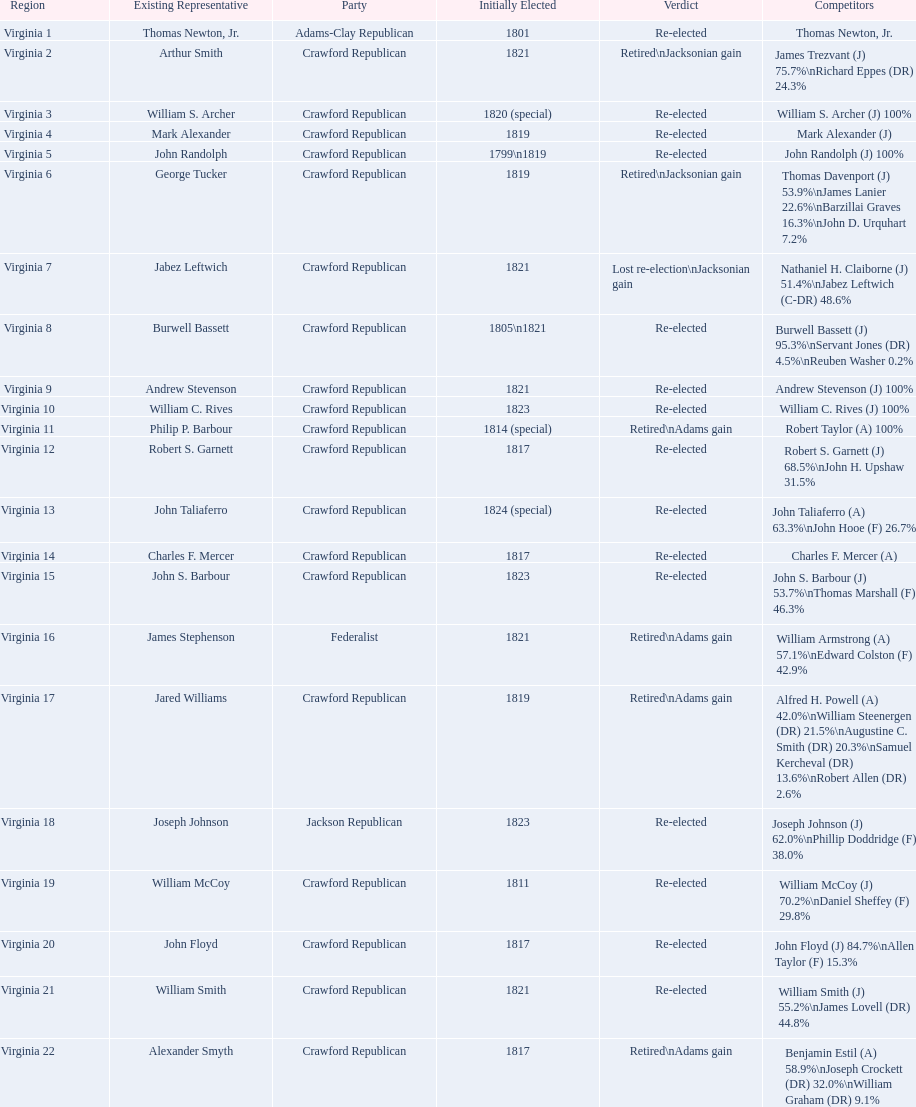How many candidates were there for virginia 17 district? 5. 